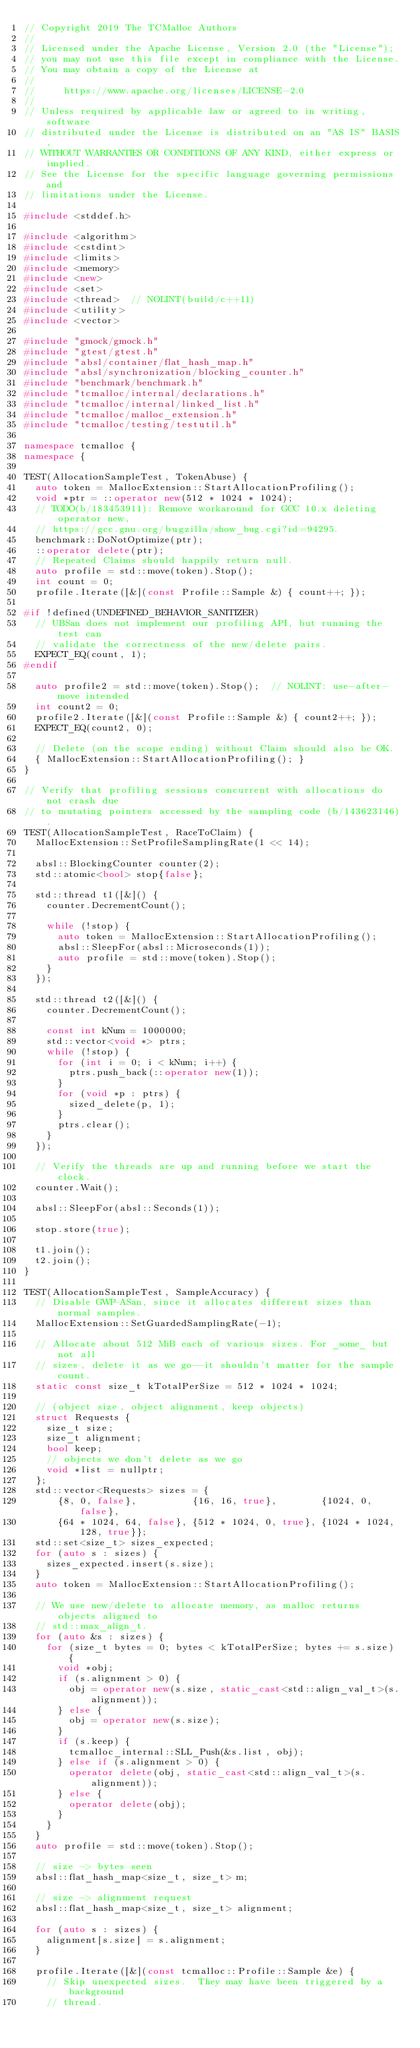<code> <loc_0><loc_0><loc_500><loc_500><_C++_>// Copyright 2019 The TCMalloc Authors
//
// Licensed under the Apache License, Version 2.0 (the "License");
// you may not use this file except in compliance with the License.
// You may obtain a copy of the License at
//
//     https://www.apache.org/licenses/LICENSE-2.0
//
// Unless required by applicable law or agreed to in writing, software
// distributed under the License is distributed on an "AS IS" BASIS,
// WITHOUT WARRANTIES OR CONDITIONS OF ANY KIND, either express or implied.
// See the License for the specific language governing permissions and
// limitations under the License.

#include <stddef.h>

#include <algorithm>
#include <cstdint>
#include <limits>
#include <memory>
#include <new>
#include <set>
#include <thread>  // NOLINT(build/c++11)
#include <utility>
#include <vector>

#include "gmock/gmock.h"
#include "gtest/gtest.h"
#include "absl/container/flat_hash_map.h"
#include "absl/synchronization/blocking_counter.h"
#include "benchmark/benchmark.h"
#include "tcmalloc/internal/declarations.h"
#include "tcmalloc/internal/linked_list.h"
#include "tcmalloc/malloc_extension.h"
#include "tcmalloc/testing/testutil.h"

namespace tcmalloc {
namespace {

TEST(AllocationSampleTest, TokenAbuse) {
  auto token = MallocExtension::StartAllocationProfiling();
  void *ptr = ::operator new(512 * 1024 * 1024);
  // TODO(b/183453911): Remove workaround for GCC 10.x deleting operator new,
  // https://gcc.gnu.org/bugzilla/show_bug.cgi?id=94295.
  benchmark::DoNotOptimize(ptr);
  ::operator delete(ptr);
  // Repeated Claims should happily return null.
  auto profile = std::move(token).Stop();
  int count = 0;
  profile.Iterate([&](const Profile::Sample &) { count++; });

#if !defined(UNDEFINED_BEHAVIOR_SANITIZER)
  // UBSan does not implement our profiling API, but running the test can
  // validate the correctness of the new/delete pairs.
  EXPECT_EQ(count, 1);
#endif

  auto profile2 = std::move(token).Stop();  // NOLINT: use-after-move intended
  int count2 = 0;
  profile2.Iterate([&](const Profile::Sample &) { count2++; });
  EXPECT_EQ(count2, 0);

  // Delete (on the scope ending) without Claim should also be OK.
  { MallocExtension::StartAllocationProfiling(); }
}

// Verify that profiling sessions concurrent with allocations do not crash due
// to mutating pointers accessed by the sampling code (b/143623146).
TEST(AllocationSampleTest, RaceToClaim) {
  MallocExtension::SetProfileSamplingRate(1 << 14);

  absl::BlockingCounter counter(2);
  std::atomic<bool> stop{false};

  std::thread t1([&]() {
    counter.DecrementCount();

    while (!stop) {
      auto token = MallocExtension::StartAllocationProfiling();
      absl::SleepFor(absl::Microseconds(1));
      auto profile = std::move(token).Stop();
    }
  });

  std::thread t2([&]() {
    counter.DecrementCount();

    const int kNum = 1000000;
    std::vector<void *> ptrs;
    while (!stop) {
      for (int i = 0; i < kNum; i++) {
        ptrs.push_back(::operator new(1));
      }
      for (void *p : ptrs) {
        sized_delete(p, 1);
      }
      ptrs.clear();
    }
  });

  // Verify the threads are up and running before we start the clock.
  counter.Wait();

  absl::SleepFor(absl::Seconds(1));

  stop.store(true);

  t1.join();
  t2.join();
}

TEST(AllocationSampleTest, SampleAccuracy) {
  // Disable GWP-ASan, since it allocates different sizes than normal samples.
  MallocExtension::SetGuardedSamplingRate(-1);

  // Allocate about 512 MiB each of various sizes. For _some_ but not all
  // sizes, delete it as we go--it shouldn't matter for the sample count.
  static const size_t kTotalPerSize = 512 * 1024 * 1024;

  // (object size, object alignment, keep objects)
  struct Requests {
    size_t size;
    size_t alignment;
    bool keep;
    // objects we don't delete as we go
    void *list = nullptr;
  };
  std::vector<Requests> sizes = {
      {8, 0, false},          {16, 16, true},        {1024, 0, false},
      {64 * 1024, 64, false}, {512 * 1024, 0, true}, {1024 * 1024, 128, true}};
  std::set<size_t> sizes_expected;
  for (auto s : sizes) {
    sizes_expected.insert(s.size);
  }
  auto token = MallocExtension::StartAllocationProfiling();

  // We use new/delete to allocate memory, as malloc returns objects aligned to
  // std::max_align_t.
  for (auto &s : sizes) {
    for (size_t bytes = 0; bytes < kTotalPerSize; bytes += s.size) {
      void *obj;
      if (s.alignment > 0) {
        obj = operator new(s.size, static_cast<std::align_val_t>(s.alignment));
      } else {
        obj = operator new(s.size);
      }
      if (s.keep) {
        tcmalloc_internal::SLL_Push(&s.list, obj);
      } else if (s.alignment > 0) {
        operator delete(obj, static_cast<std::align_val_t>(s.alignment));
      } else {
        operator delete(obj);
      }
    }
  }
  auto profile = std::move(token).Stop();

  // size -> bytes seen
  absl::flat_hash_map<size_t, size_t> m;

  // size -> alignment request
  absl::flat_hash_map<size_t, size_t> alignment;

  for (auto s : sizes) {
    alignment[s.size] = s.alignment;
  }

  profile.Iterate([&](const tcmalloc::Profile::Sample &e) {
    // Skip unexpected sizes.  They may have been triggered by a background
    // thread.</code> 